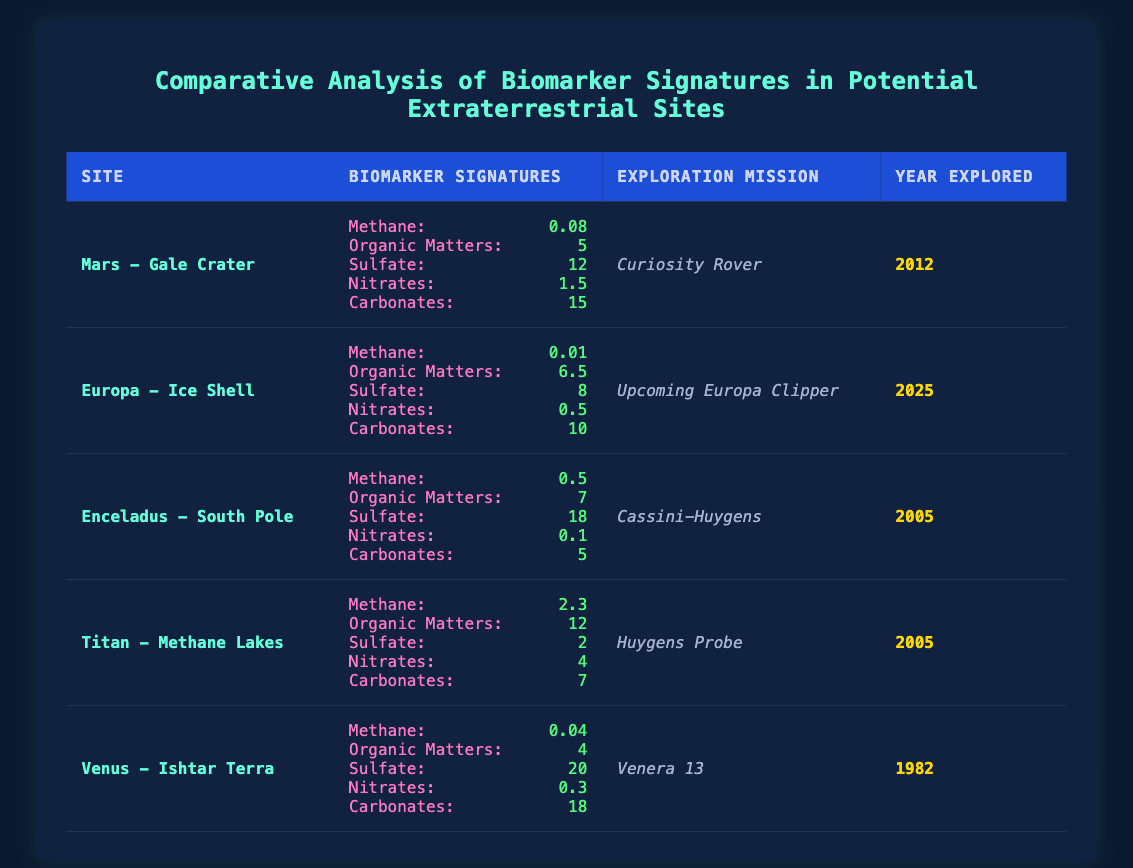What is the methane value for Titan - Methane Lakes? The methane value for Titan - Methane Lakes is found in the biomarker signatures section of the table. Under that column for Titan, the value indicated is 2.3.
Answer: 2.3 Which exploration mission explored Mars - Gale Crater? The exploration mission for Mars - Gale Crater is listed in the relevant column of the table, which states "Curiosity Rover."
Answer: Curiosity Rover Is there a higher nitrate value in Enceladus - South Pole than in Venus - Ishtar Terra? Comparing the nitrate values from both sites, Enceladus has a value of 0.1 while Venus has a value of 0.3. Since 0.1 is less than 0.3, the statement is false.
Answer: No What is the total amount of organic matters from the sites explored by the Huygens Probe? The Huygens Probe explored Titan - Methane Lakes, which has an organic matters value of 12. There are no other entries for Huygens Probe, so the total is 12.
Answer: 12 Which extraterrestrial site has the highest sulfate value? Looking at the sulfate values in the table, we see that Venus - Ishtar Terra has a sulfate value of 20, higher than any other site listed.
Answer: Venus - Ishtar Terra What is the average value of carbonates from all the sites listed? The carbonate values from the sites are: Mars - 15, Europa - 10, Enceladus - 5, Titan - 7, Venus - 18. Summing these gives 15 + 10 + 5 + 7 + 18 = 55. There are 5 sites, so the average is 55/5 = 11.
Answer: 11 Does Europa - Ice Shell have higher organic matters than Mars - Gale Crater? The organic matters for Europa is 6.5 and for Mars is 5. Since 6.5 is greater than 5, the statement is true.
Answer: Yes What is the difference in methane values between Titan - Methane Lakes and Mars - Gale Crater? The methane value for Titan is 2.3 and for Mars it is 0.08. The difference is calculated as 2.3 - 0.08 = 2.22.
Answer: 2.22 Which site was explored first based on the year explored? By examining the "Year Explored" column, Venus - Ishtar Terra was explored in 1982, which is earlier than all other sites listed.
Answer: Venus - Ishtar Terra 